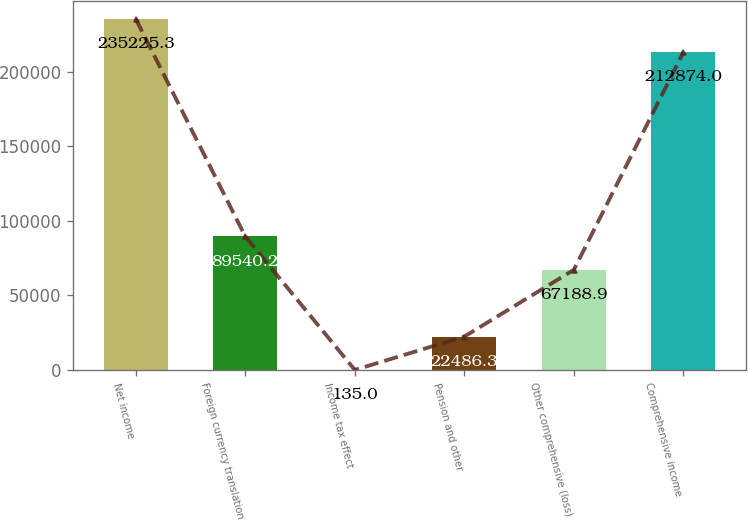Convert chart to OTSL. <chart><loc_0><loc_0><loc_500><loc_500><bar_chart><fcel>Net income<fcel>Foreign currency translation<fcel>Income tax effect<fcel>Pension and other<fcel>Other comprehensive (loss)<fcel>Comprehensive income<nl><fcel>235225<fcel>89540.2<fcel>135<fcel>22486.3<fcel>67188.9<fcel>212874<nl></chart> 